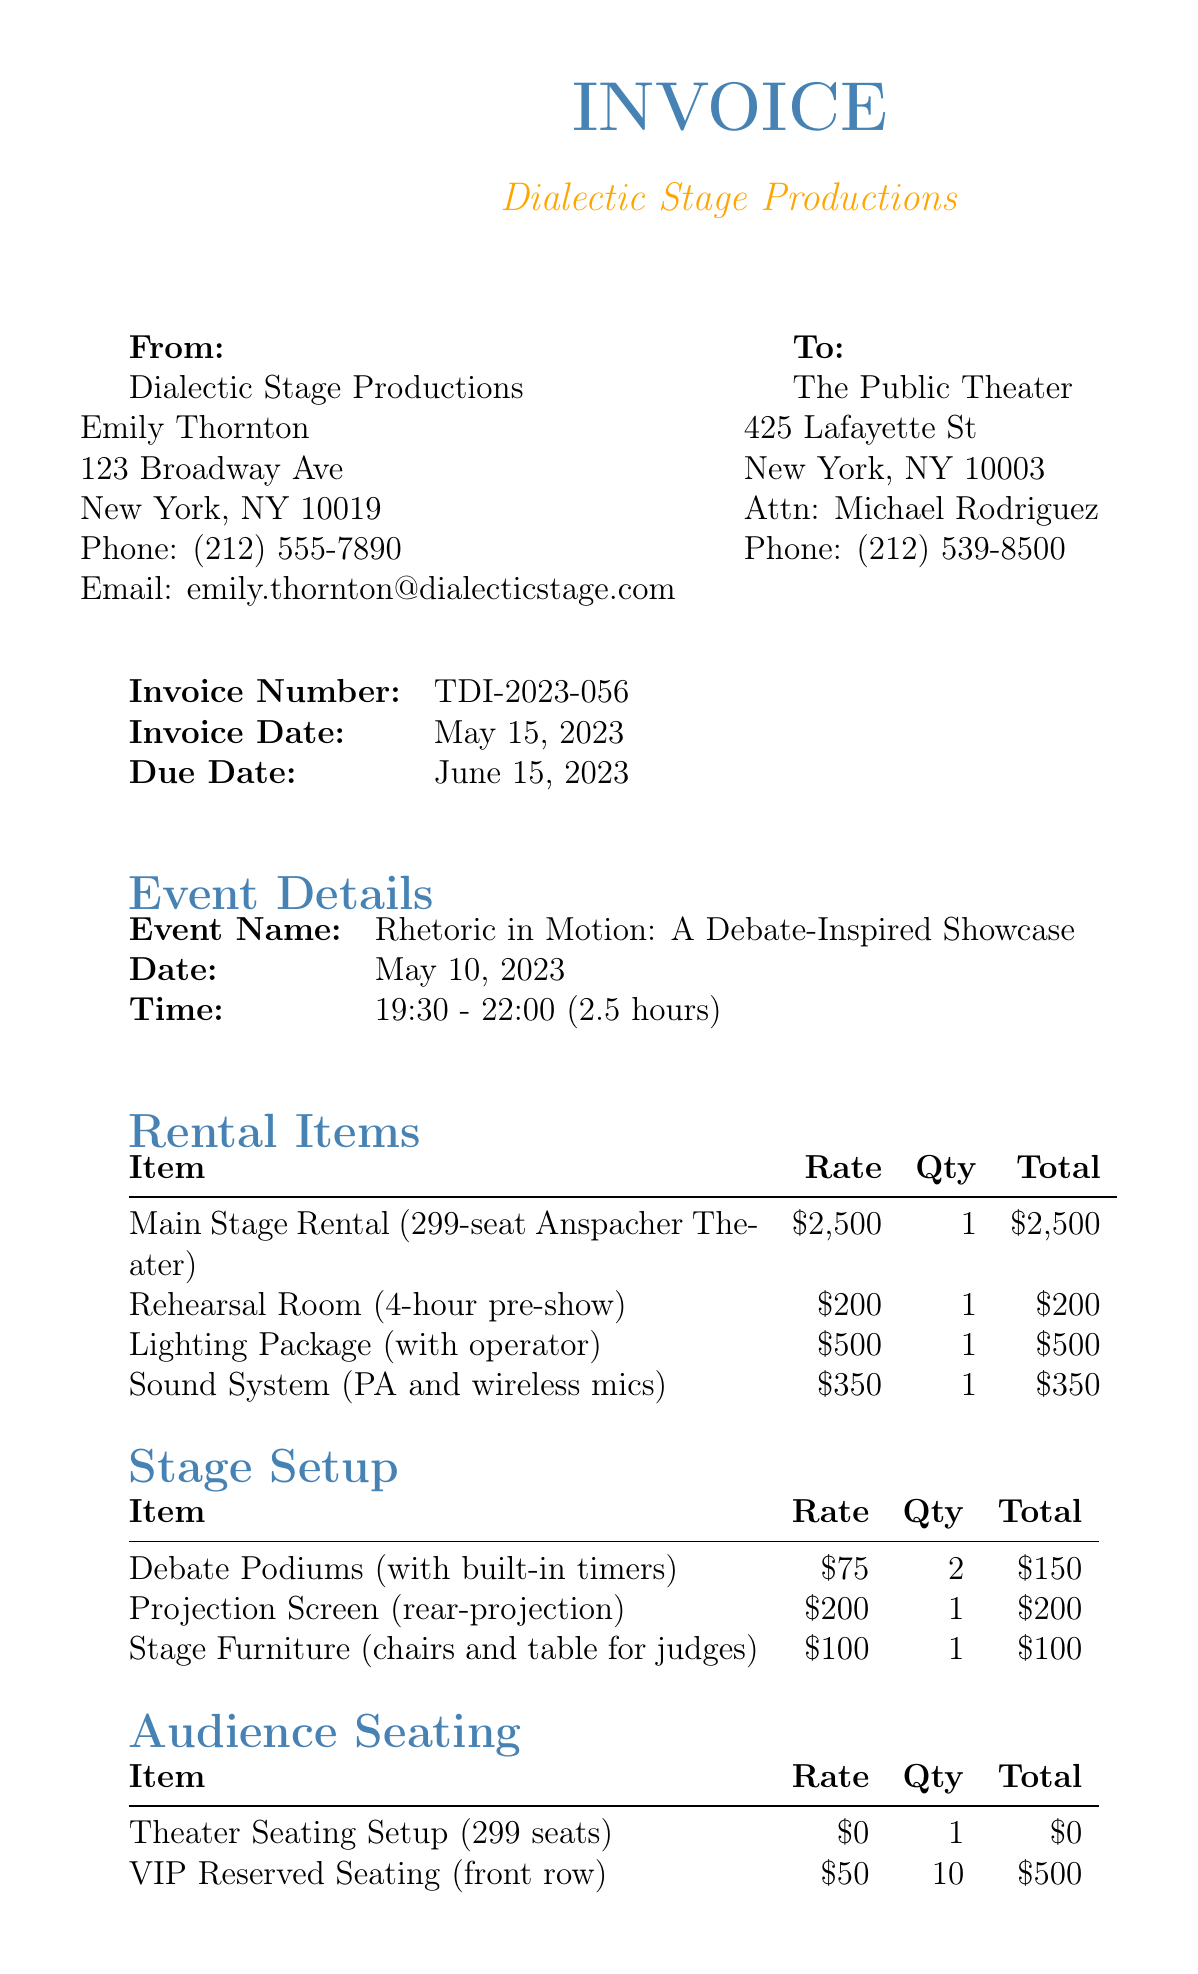What is the invoice number? The invoice number is clearly stated in the invoice details section.
Answer: TDI-2023-056 Who is the director of Dialectic Stage Productions? The director's name is listed in the theater company information.
Answer: Emily Thornton What is the due date for the invoice? The due date for the invoice is mentioned in the invoice details.
Answer: June 15, 2023 How many total seats are in the Anspacher Theater? The seating capacity of the theater is specified in the rental items section of the document.
Answer: 299 What is the total amount due? The total amount due is provided at the end of the invoice summary.
Answer: $5,253.22 What was the duration of the debate showcase? The duration of the event is noted in the event details.
Answer: 2.5 hours What item has a rate of 75? This refers to the items listed in the stage setup section; it can be found by looking at the rates of the items.
Answer: Debate Podiums How many VIP reserved seats were arranged? The quantity of VIP reserved seats is detailed in the audience seating section.
Answer: 10 What is the tax rate applied to the invoice? The tax rate is explicitly stated in the invoice summary area of the document.
Answer: 8.875% 